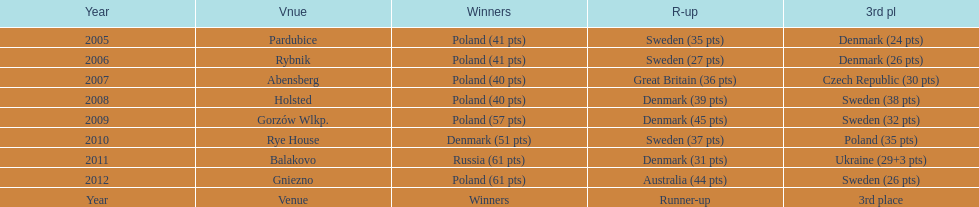When was the first year that poland did not place in the top three positions of the team speedway junior world championship? 2011. 